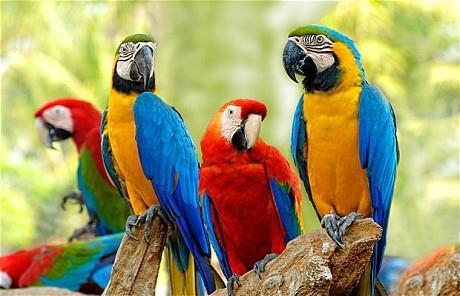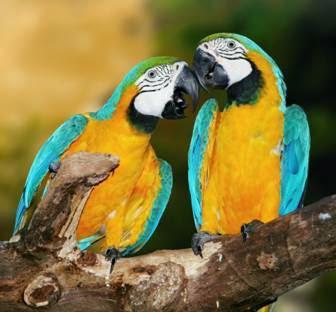The first image is the image on the left, the second image is the image on the right. Examine the images to the left and right. Is the description "Exactly four parrots are shown, two in each image, all of them with the same eye design and gold chests, one pair looking at each other, while one pair looks in the same direction." accurate? Answer yes or no. No. The first image is the image on the left, the second image is the image on the right. Given the left and right images, does the statement "One image includes a red-feathered parrot along with a blue-and-yellow parrot." hold true? Answer yes or no. Yes. 